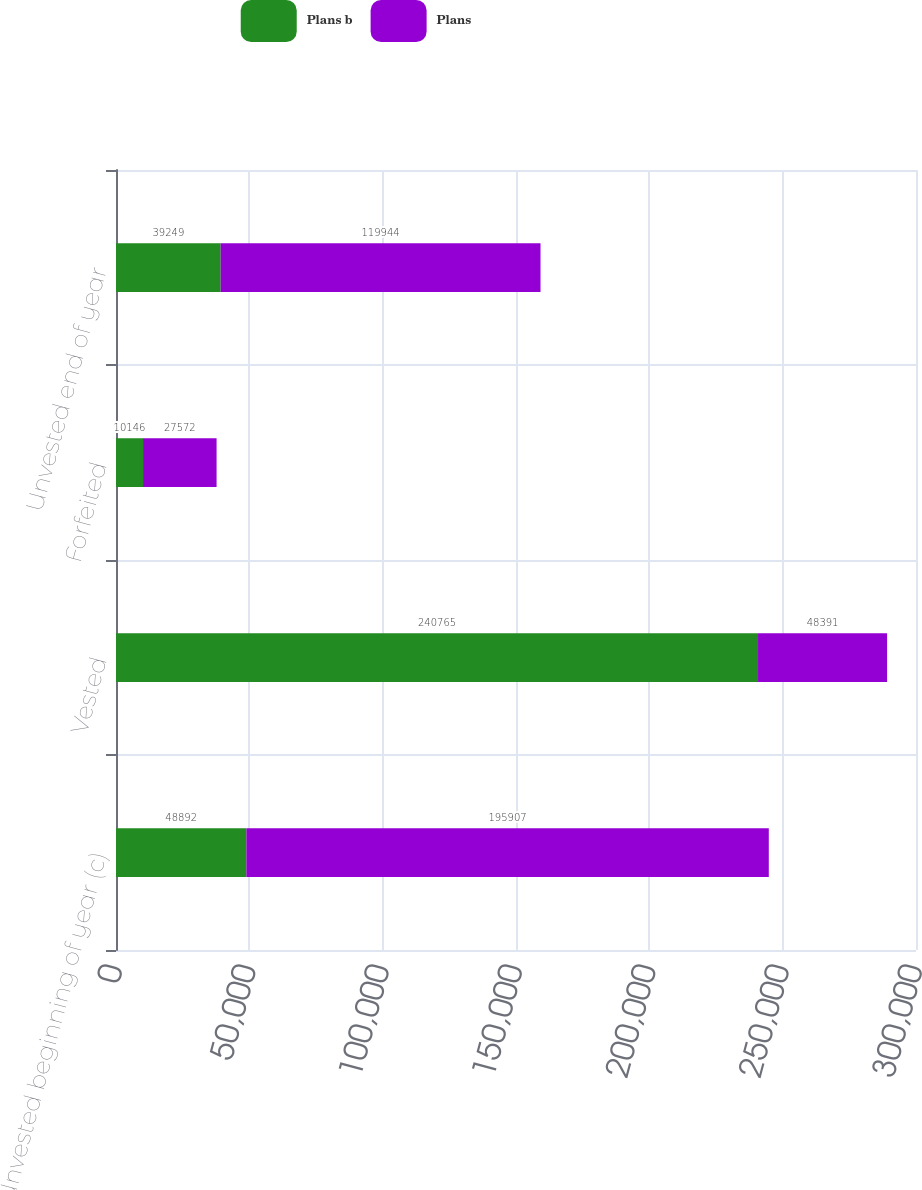Convert chart. <chart><loc_0><loc_0><loc_500><loc_500><stacked_bar_chart><ecel><fcel>Unvested beginning of year (c)<fcel>Vested<fcel>Forfeited<fcel>Unvested end of year<nl><fcel>Plans b<fcel>48892<fcel>240765<fcel>10146<fcel>39249<nl><fcel>Plans<fcel>195907<fcel>48391<fcel>27572<fcel>119944<nl></chart> 